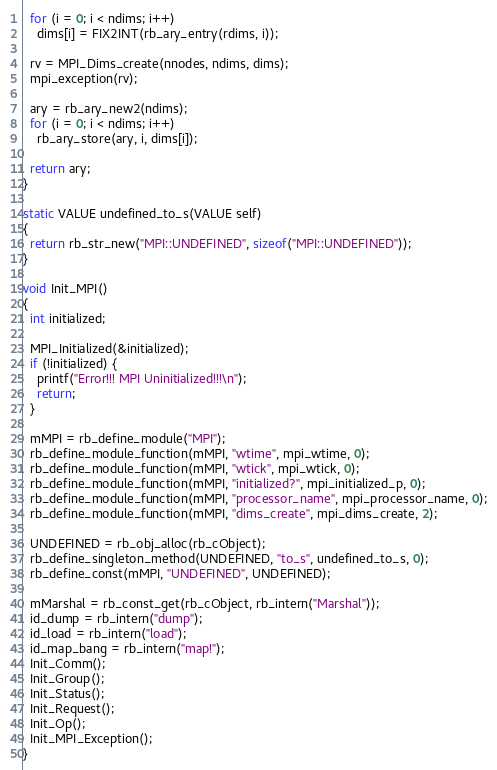Convert code to text. <code><loc_0><loc_0><loc_500><loc_500><_C_>  for (i = 0; i < ndims; i++)
    dims[i] = FIX2INT(rb_ary_entry(rdims, i));

  rv = MPI_Dims_create(nnodes, ndims, dims);
  mpi_exception(rv);

  ary = rb_ary_new2(ndims);
  for (i = 0; i < ndims; i++)
    rb_ary_store(ary, i, dims[i]);

  return ary;
}

static VALUE undefined_to_s(VALUE self)
{
  return rb_str_new("MPI::UNDEFINED", sizeof("MPI::UNDEFINED"));
}

void Init_MPI()
{
  int initialized;

  MPI_Initialized(&initialized);
  if (!initialized) {
    printf("Error!!! MPI Uninitialized!!!\n");
    return;
  }

  mMPI = rb_define_module("MPI");
  rb_define_module_function(mMPI, "wtime", mpi_wtime, 0);
  rb_define_module_function(mMPI, "wtick", mpi_wtick, 0);
  rb_define_module_function(mMPI, "initialized?", mpi_initialized_p, 0);
  rb_define_module_function(mMPI, "processor_name", mpi_processor_name, 0);
  rb_define_module_function(mMPI, "dims_create", mpi_dims_create, 2);

  UNDEFINED = rb_obj_alloc(rb_cObject);
  rb_define_singleton_method(UNDEFINED, "to_s", undefined_to_s, 0);
  rb_define_const(mMPI, "UNDEFINED", UNDEFINED);

  mMarshal = rb_const_get(rb_cObject, rb_intern("Marshal"));
  id_dump = rb_intern("dump");
  id_load = rb_intern("load");
  id_map_bang = rb_intern("map!");
  Init_Comm();
  Init_Group();
  Init_Status();
  Init_Request();
  Init_Op();
  Init_MPI_Exception();
}
</code> 